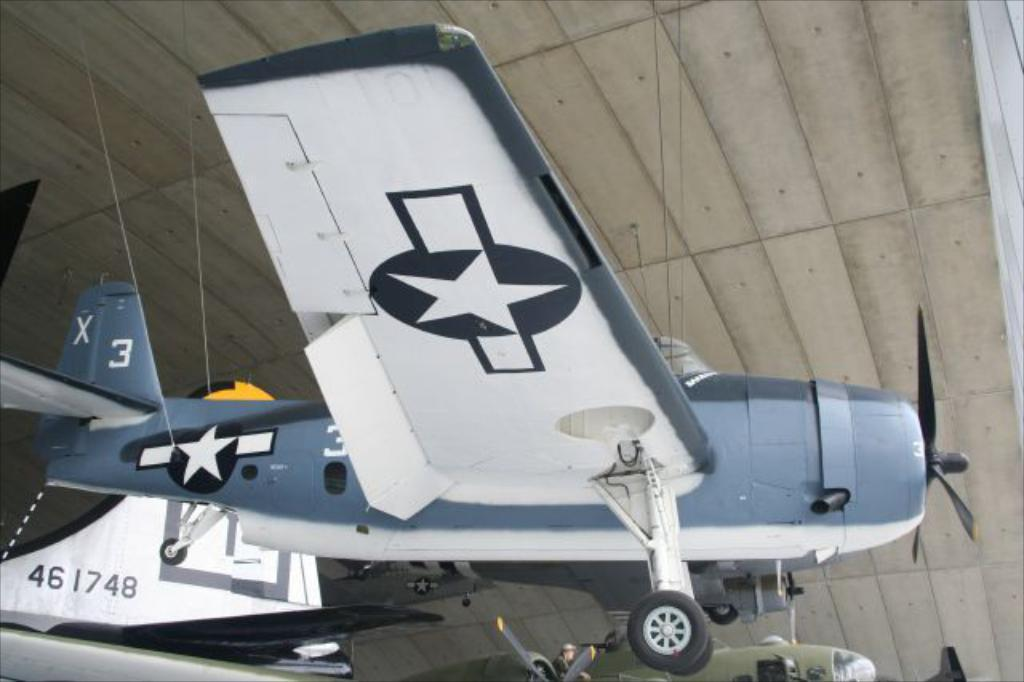What is the main subject of the image? The main subject of the image is an aircraft. Can you describe the colors of the aircraft? The aircraft is in white and gray color. Are there any people visible in the image? Yes, there is a person visible in the image. What type of meat is being prepared by the person in the image? There is no meat or any indication of food preparation in the image. Can you see a rake in the image? There is no rake present in the image. 